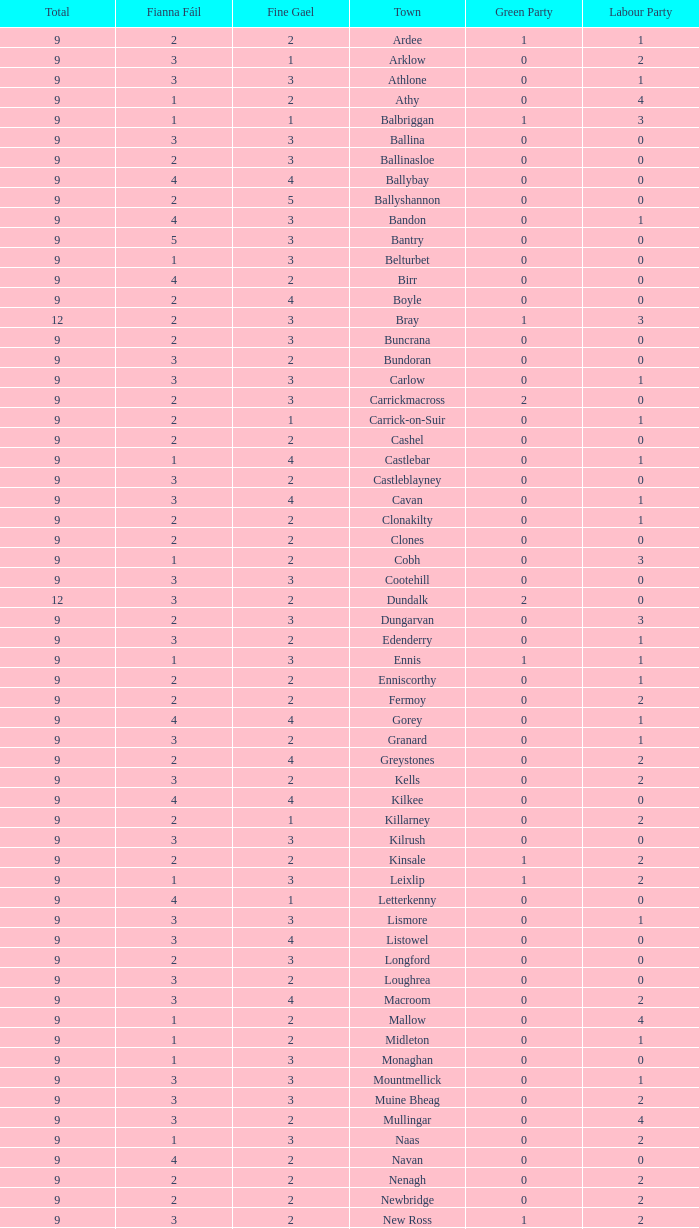What is the lowest number in the Labour Party for the Fianna Fail higher than 5? None. 